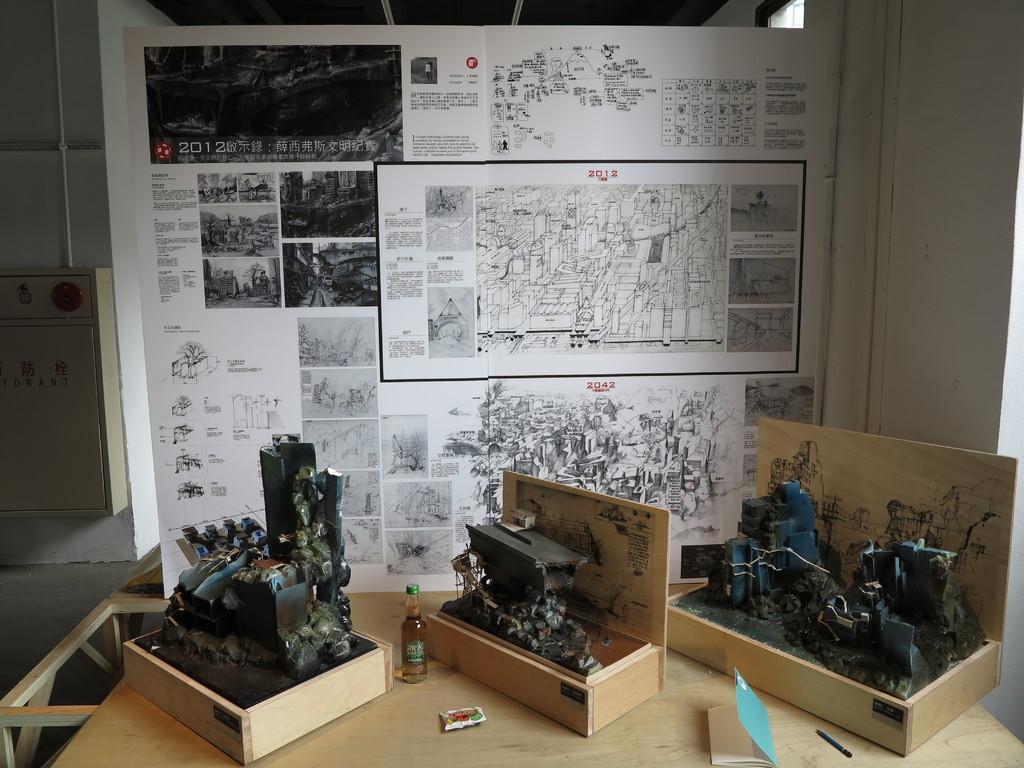How would you summarize this image in a sentence or two? In this picture we can see a few engines in the wooden boxes. There is a bottle, book, pencil and an object is visible on a wooden table. We can see some text, numbers and a few figures on a whiteboard. There is some text visible on an object on the left side. 